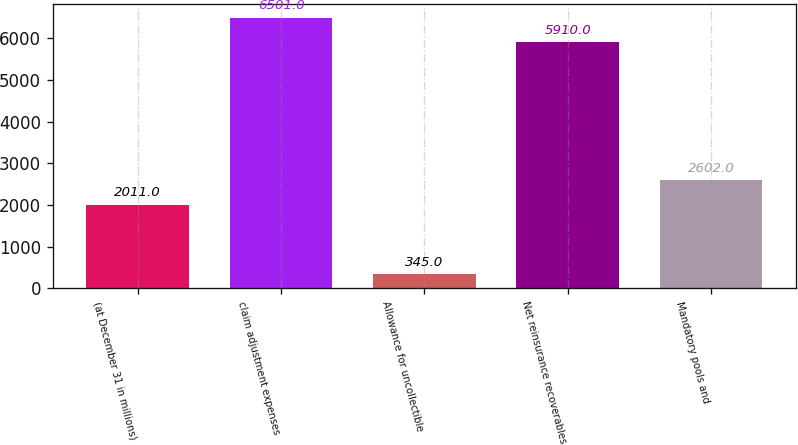<chart> <loc_0><loc_0><loc_500><loc_500><bar_chart><fcel>(at December 31 in millions)<fcel>claim adjustment expenses<fcel>Allowance for uncollectible<fcel>Net reinsurance recoverables<fcel>Mandatory pools and<nl><fcel>2011<fcel>6501<fcel>345<fcel>5910<fcel>2602<nl></chart> 